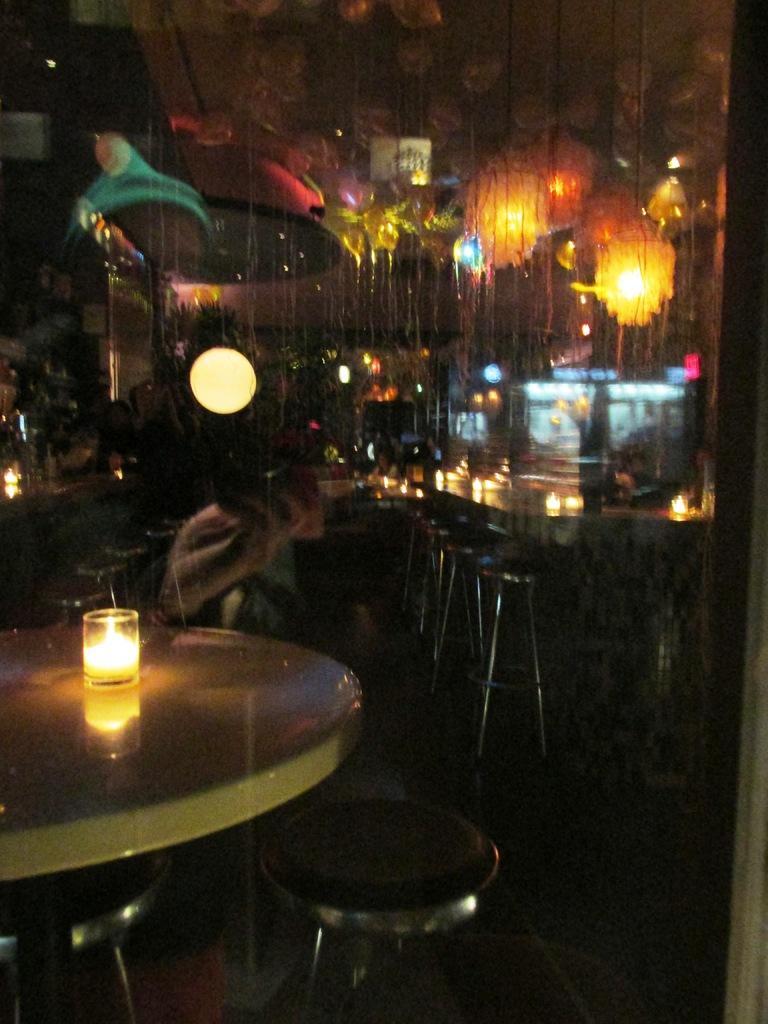How would you summarize this image in a sentence or two? In this picture we can see a candle in a glass. There are few chairs and tables. We can see some lights on top. 